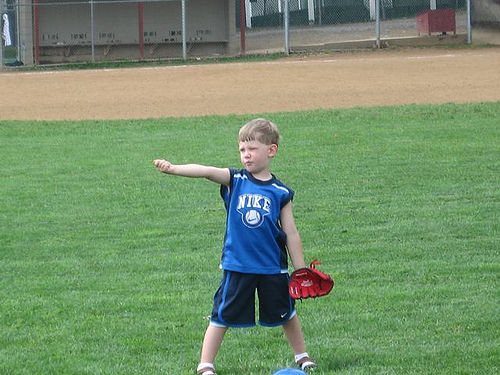What can you tell about the environment surrounding the boy? The boy is playing in a grassy field which is likely a local park or a school sports ground. The presence of a bench in the dugout and a metal chain link fence suggests this area is equipped for children's sports activities. 